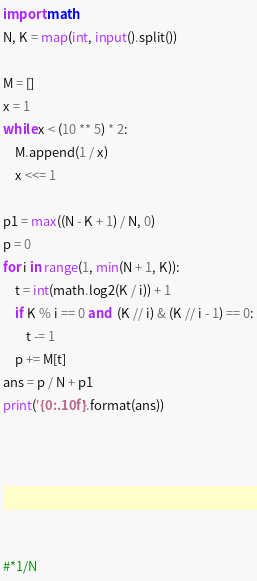Convert code to text. <code><loc_0><loc_0><loc_500><loc_500><_Python_>import math
N, K = map(int, input().split())

M = []
x = 1
while x < (10 ** 5) * 2:
    M.append(1 / x)
    x <<= 1

p1 = max((N - K + 1) / N, 0)
p = 0
for i in range(1, min(N + 1, K)):
    t = int(math.log2(K / i)) + 1
    if K % i == 0 and  (K // i) & (K // i - 1) == 0:
        t -= 1
    p += M[t]
ans = p / N + p1
print('{0:.10f}'.format(ans))






#*1/N
</code> 